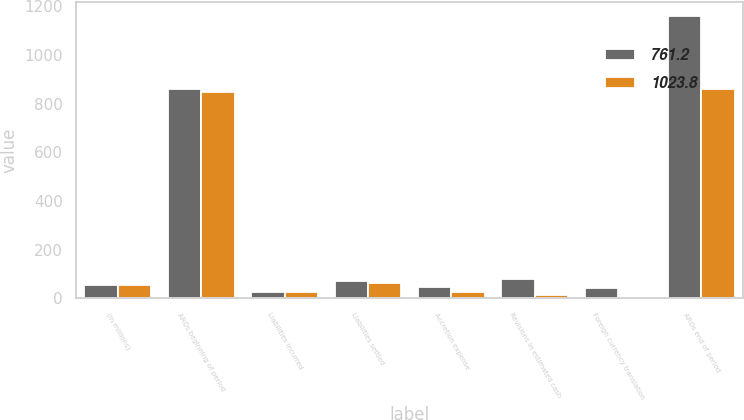<chart> <loc_0><loc_0><loc_500><loc_500><stacked_bar_chart><ecel><fcel>(in millions)<fcel>AROs beginning of period<fcel>Liabilities incurred<fcel>Liabilities settled<fcel>Accretion expense<fcel>Revisions in estimated cash<fcel>Foreign currency translation<fcel>AROs end of period<nl><fcel>761.2<fcel>56.4<fcel>859.3<fcel>27.8<fcel>69.6<fcel>48<fcel>78.2<fcel>42.5<fcel>1160.1<nl><fcel>1023.8<fcel>56.4<fcel>849.9<fcel>27.1<fcel>64.8<fcel>25.7<fcel>15.7<fcel>5.7<fcel>859.3<nl></chart> 